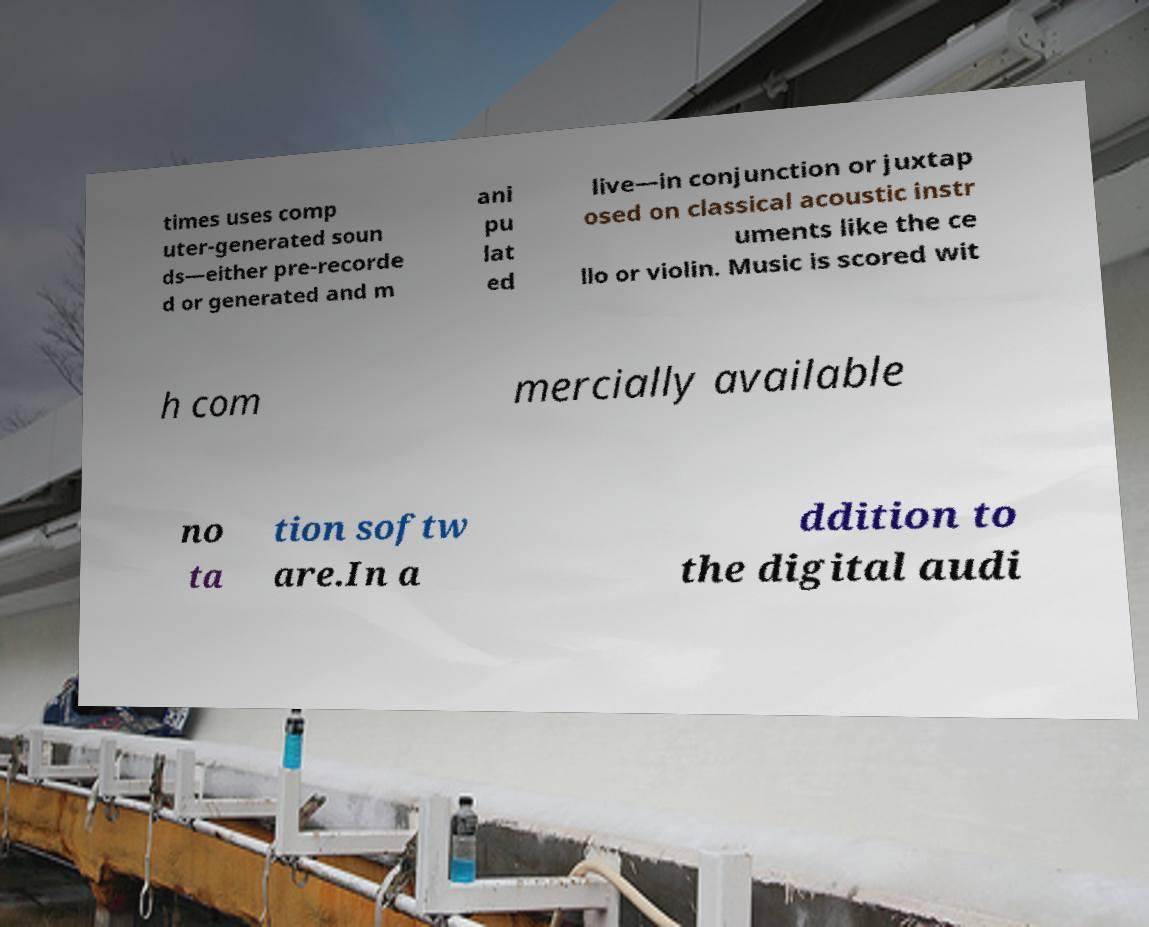Please read and relay the text visible in this image. What does it say? times uses comp uter-generated soun ds—either pre-recorde d or generated and m ani pu lat ed live—in conjunction or juxtap osed on classical acoustic instr uments like the ce llo or violin. Music is scored wit h com mercially available no ta tion softw are.In a ddition to the digital audi 